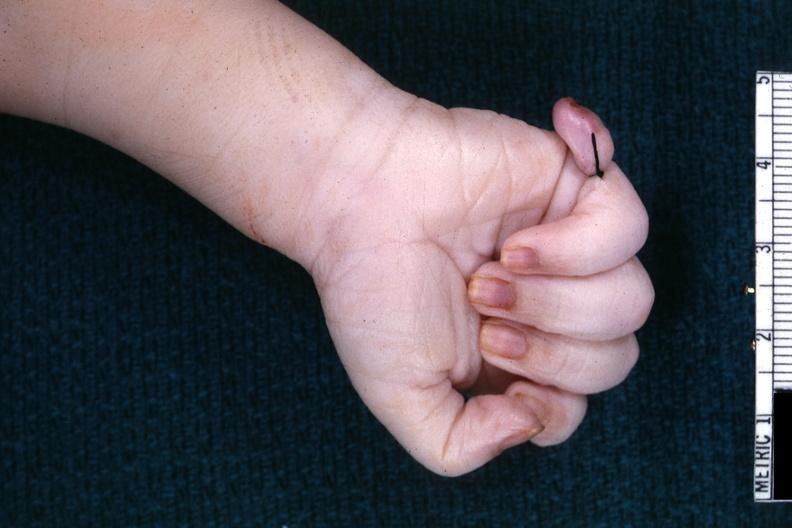what is present?
Answer the question using a single word or phrase. Supernumerary digit 